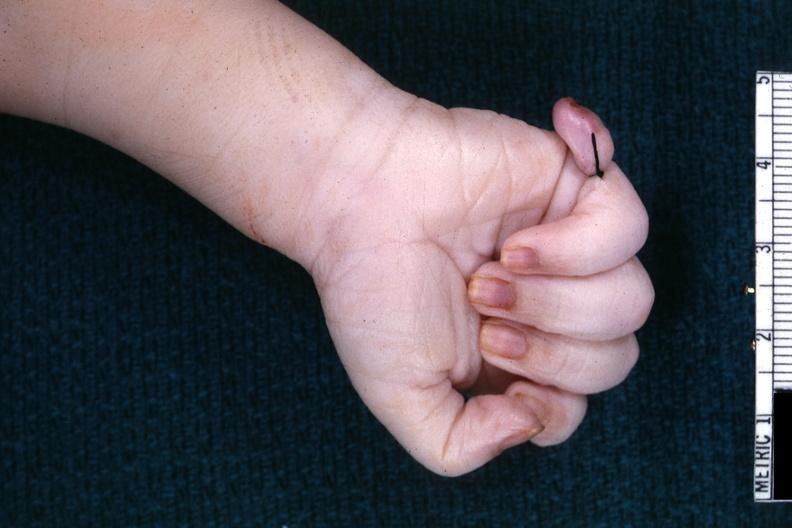what is present?
Answer the question using a single word or phrase. Supernumerary digit 